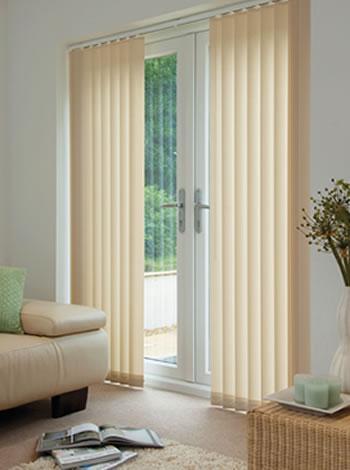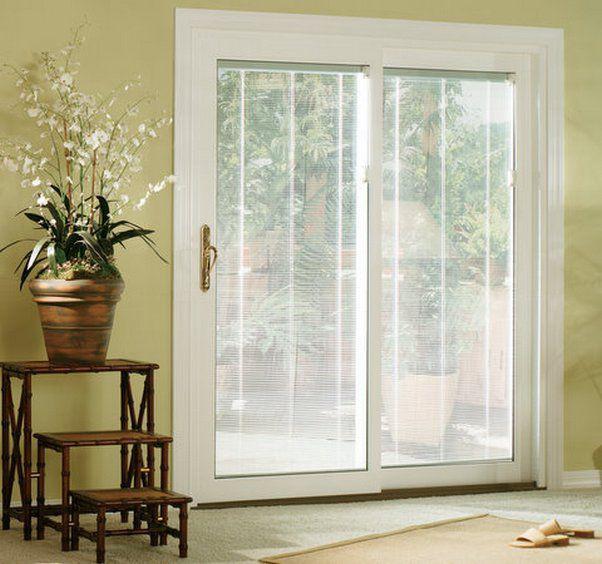The first image is the image on the left, the second image is the image on the right. For the images shown, is this caption "There is a sofa/chair near the tall window, in the left image." true? Answer yes or no. Yes. 